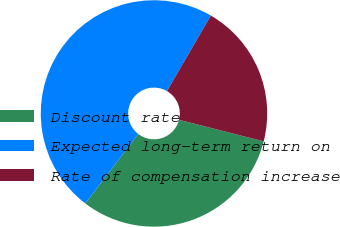<chart> <loc_0><loc_0><loc_500><loc_500><pie_chart><fcel>Discount rate<fcel>Expected long-term return on<fcel>Rate of compensation increase<nl><fcel>31.41%<fcel>48.0%<fcel>20.59%<nl></chart> 